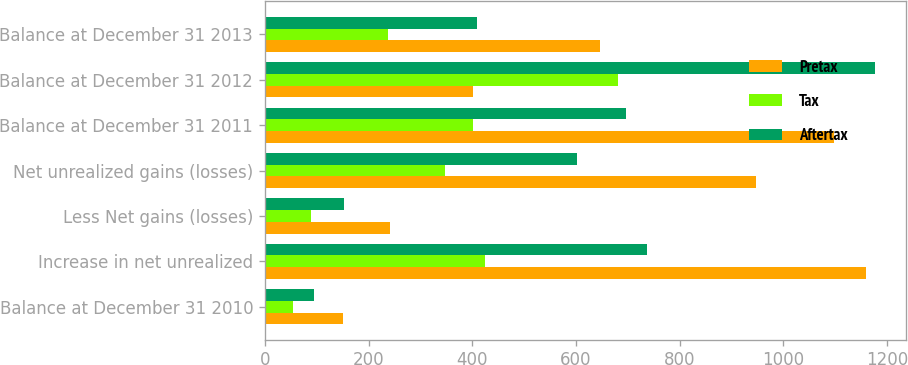<chart> <loc_0><loc_0><loc_500><loc_500><stacked_bar_chart><ecel><fcel>Balance at December 31 2010<fcel>Increase in net unrealized<fcel>Less Net gains (losses)<fcel>Net unrealized gains (losses)<fcel>Balance at December 31 2011<fcel>Balance at December 31 2012<fcel>Balance at December 31 2013<nl><fcel>Pretax<fcel>150<fcel>1160<fcel>241<fcel>948<fcel>1098<fcel>402<fcel>647<nl><fcel>Tax<fcel>55<fcel>424<fcel>88<fcel>347<fcel>402<fcel>681<fcel>238<nl><fcel>Aftertax<fcel>95<fcel>736<fcel>153<fcel>601<fcel>696<fcel>1177<fcel>409<nl></chart> 